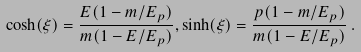<formula> <loc_0><loc_0><loc_500><loc_500>\cosh ( \xi ) = \frac { E ( 1 - m / E _ { p } ) } { m ( 1 - E / E _ { p } ) } , \sinh ( \xi ) = \frac { p ( 1 - m / E _ { p } ) } { m ( 1 - E / E _ { p } ) } \, .</formula> 